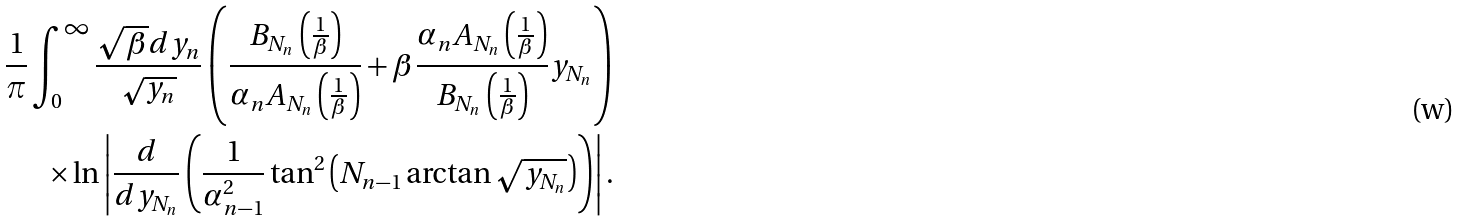Convert formula to latex. <formula><loc_0><loc_0><loc_500><loc_500>\frac { 1 } { \pi } \int _ { 0 } ^ { \infty } \frac { \sqrt { \beta } d y _ { n } } { \sqrt { y _ { n } } } \left ( \frac { B _ { N _ { n } } \left ( \frac { 1 } { \beta } \right ) } { \alpha _ { n } A _ { N _ { n } } \left ( \frac { 1 } { \beta } \right ) } + \beta \frac { \alpha _ { n } A _ { N _ { n } } \left ( \frac { 1 } { \beta } \right ) } { B _ { N _ { n } } \left ( \frac { 1 } { \beta } \right ) } y _ { N _ { n } } \right ) \\ \times \ln \left | \frac { d } { d y _ { N _ { n } } } \left ( \frac { 1 } { \alpha _ { n - 1 } ^ { 2 } } \tan ^ { 2 } \left ( N _ { n - 1 } \arctan \sqrt { y _ { N _ { n } } } \right ) \right ) \right | .</formula> 